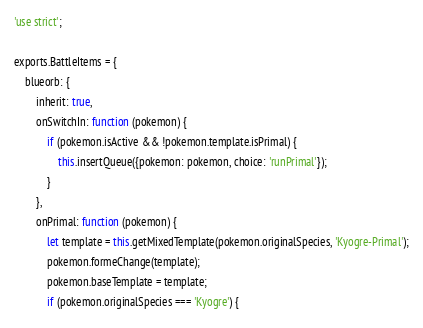Convert code to text. <code><loc_0><loc_0><loc_500><loc_500><_JavaScript_>'use strict';

exports.BattleItems = {
	blueorb: {
		inherit: true,
		onSwitchIn: function (pokemon) {
			if (pokemon.isActive && !pokemon.template.isPrimal) {
				this.insertQueue({pokemon: pokemon, choice: 'runPrimal'});
			}
		},
		onPrimal: function (pokemon) {
			let template = this.getMixedTemplate(pokemon.originalSpecies, 'Kyogre-Primal');
			pokemon.formeChange(template);
			pokemon.baseTemplate = template;
			if (pokemon.originalSpecies === 'Kyogre') {</code> 